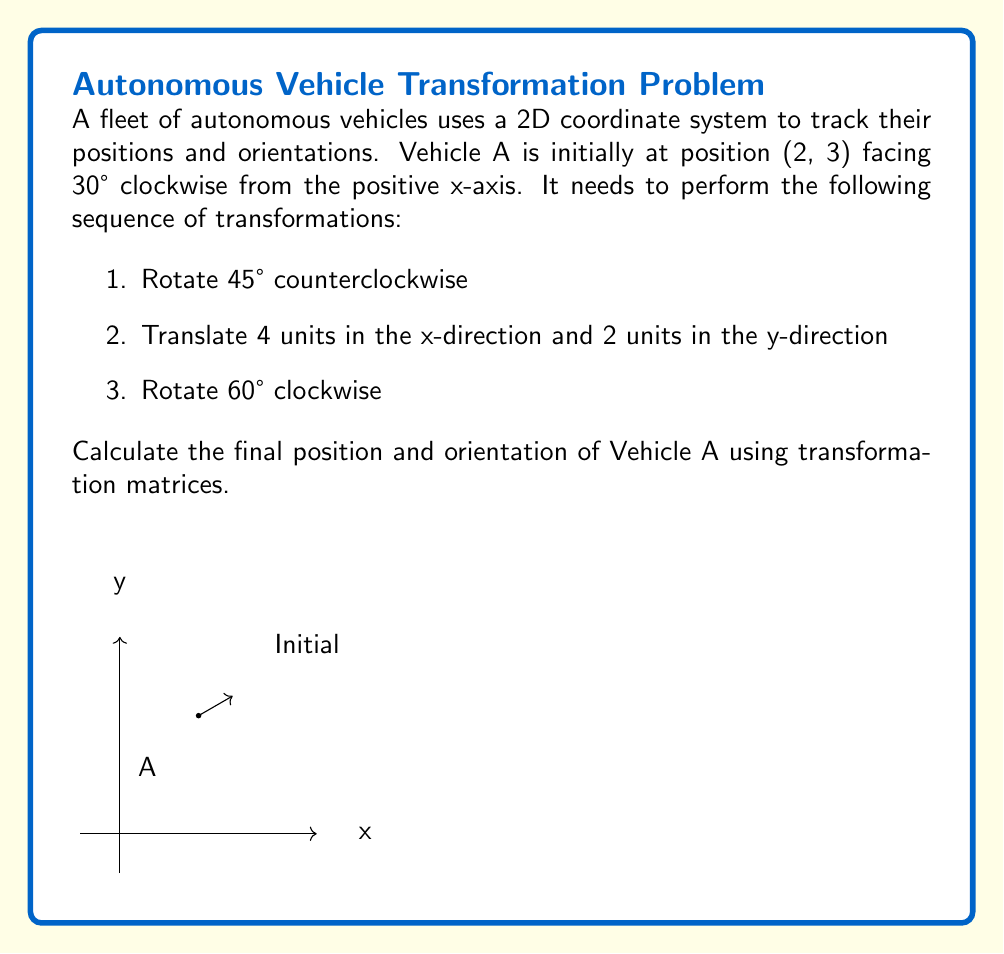Provide a solution to this math problem. Let's approach this step-by-step:

1) First, we need to represent the initial position and orientation of Vehicle A as a homogeneous transformation matrix:

   $$T_i = \begin{bmatrix}
   \cos(30°) & -\sin(30°) & 2 \\
   \sin(30°) & \cos(30°) & 3 \\
   0 & 0 & 1
   \end{bmatrix}$$

2) Now, let's create matrices for each transformation:

   Rotation by 45° counterclockwise:
   $$R_1 = \begin{bmatrix}
   \cos(45°) & -\sin(45°) & 0 \\
   \sin(45°) & \cos(45°) & 0 \\
   0 & 0 & 1
   \end{bmatrix}$$

   Translation by (4, 2):
   $$T = \begin{bmatrix}
   1 & 0 & 4 \\
   0 & 1 & 2 \\
   0 & 0 & 1
   \end{bmatrix}$$

   Rotation by 60° clockwise:
   $$R_2 = \begin{bmatrix}
   \cos(-60°) & -\sin(-60°) & 0 \\
   \sin(-60°) & \cos(-60°) & 0 \\
   0 & 0 & 1
   \end{bmatrix}$$

3) The final transformation matrix is the product of these matrices in the correct order:

   $$T_f = R_2 \cdot T \cdot R_1 \cdot T_i$$

4) Multiplying these matrices (which can be done using a calculator or computer):

   $$T_f = \begin{bmatrix}
   -0.3660 & -0.9307 & 4.9282 \\
   0.9307 & -0.3660 & 4.9923 \\
   0 & 0 & 1
   \end{bmatrix}$$

5) From this final transformation matrix, we can extract:
   - The final position: (4.9282, 4.9923)
   - The final orientation: $\theta = \arctan2(0.9307, -0.3660) = 111.4°$ clockwise from the positive x-axis
Answer: Position: (4.9282, 4.9923), Orientation: 111.4° clockwise from +x-axis 